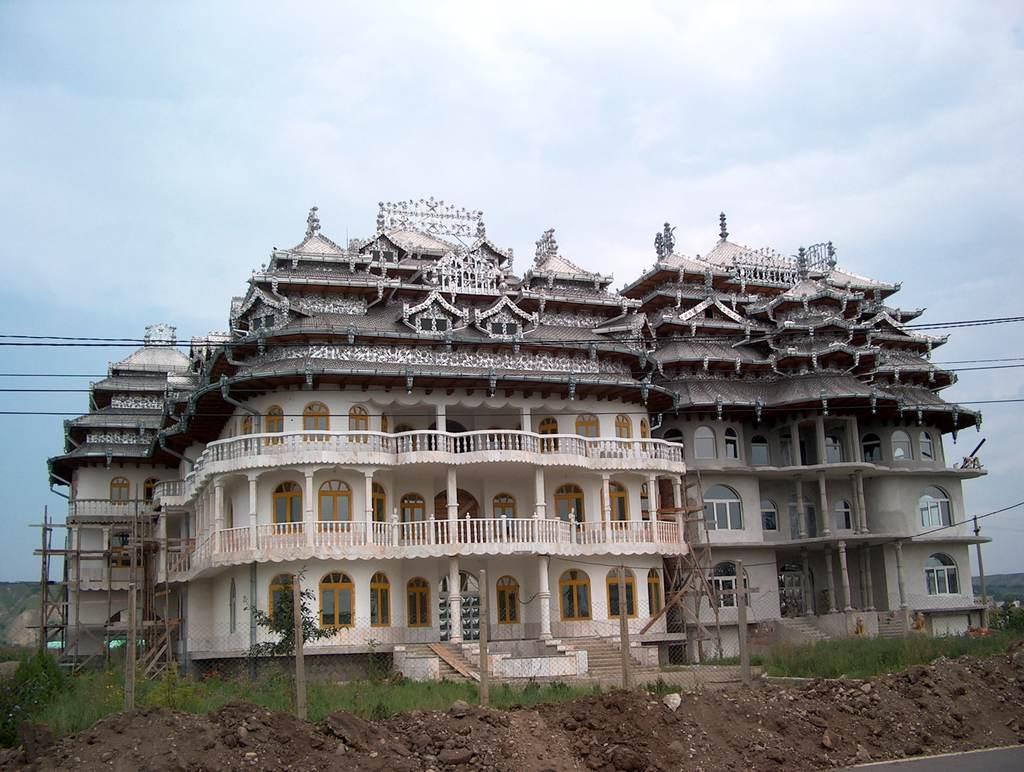What type of structures can be seen in the image? There are houses in the image. What type of natural elements are present in the image? There are trees in the image. What type of terrain is visible in the image? There is mud visible in the image. What type of man-made structures can be seen in the image? There are wires in the image. What is visible in the background of the image? The sky is visible in the background of the image. What can be seen in the sky in the image? There are clouds in the sky. Where is the dock located in the image? There is no dock present in the image. What type of treatment is being administered to the trees in the image? There is no treatment being administered to the trees in the image; they are simply standing. How can someone join the wires in the image? The wires in the image are not meant to be joined; they are simply present in the image. 